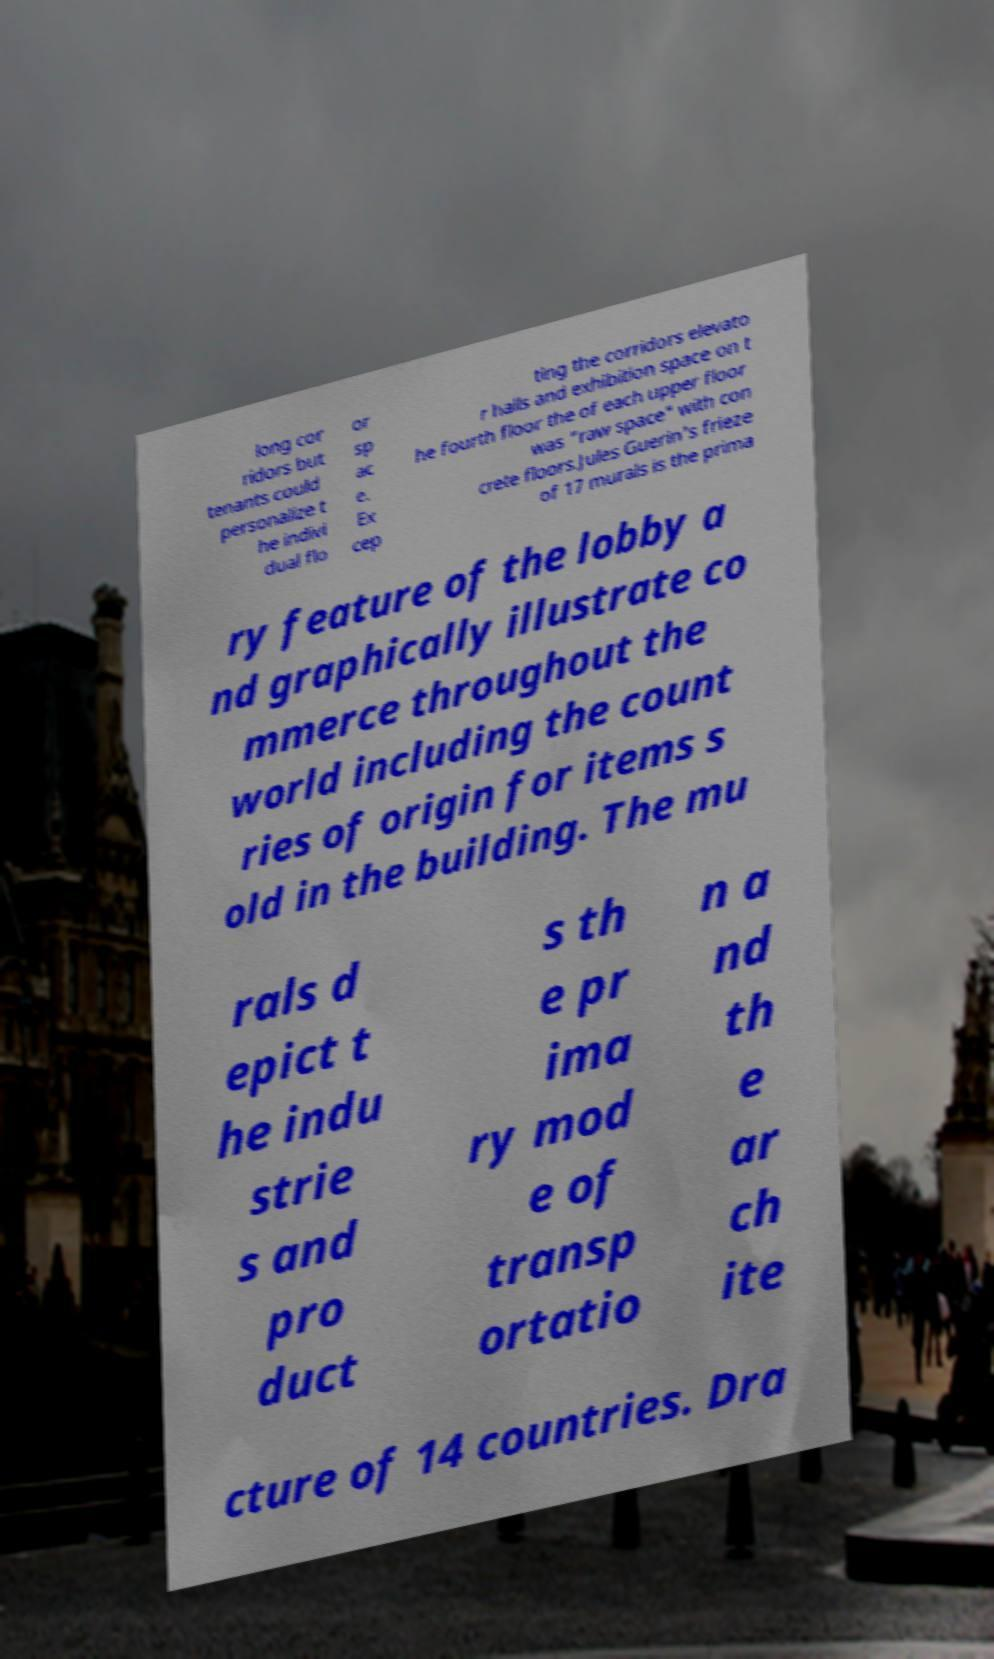I need the written content from this picture converted into text. Can you do that? long cor ridors but tenants could personalize t he indivi dual flo or sp ac e. Ex cep ting the corridors elevato r halls and exhibition space on t he fourth floor the of each upper floor was "raw space" with con crete floors.Jules Guerin's frieze of 17 murals is the prima ry feature of the lobby a nd graphically illustrate co mmerce throughout the world including the count ries of origin for items s old in the building. The mu rals d epict t he indu strie s and pro duct s th e pr ima ry mod e of transp ortatio n a nd th e ar ch ite cture of 14 countries. Dra 